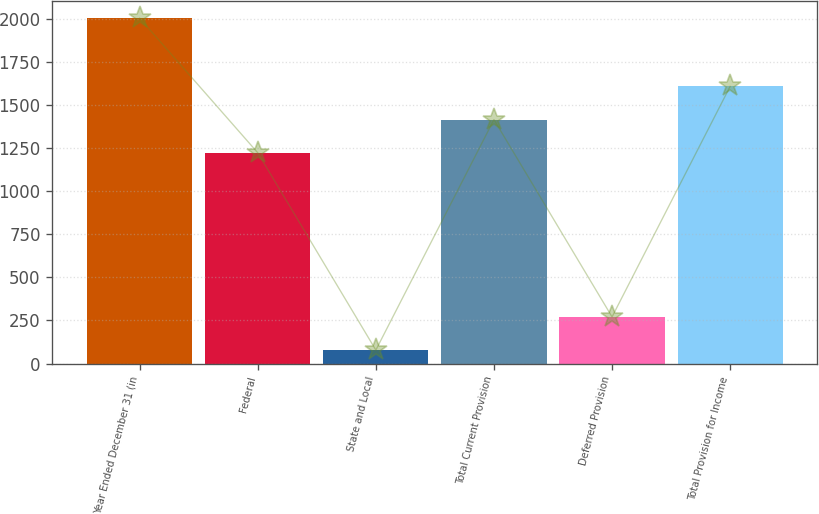Convert chart to OTSL. <chart><loc_0><loc_0><loc_500><loc_500><bar_chart><fcel>Year Ended December 31 (in<fcel>Federal<fcel>State and Local<fcel>Total Current Provision<fcel>Deferred Provision<fcel>Total Provision for Income<nl><fcel>2004<fcel>1223<fcel>78<fcel>1415.6<fcel>270.6<fcel>1608.2<nl></chart> 